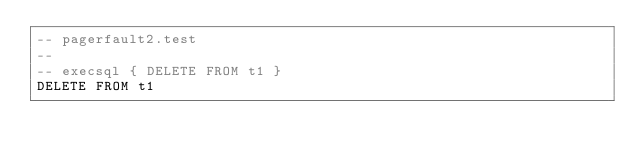<code> <loc_0><loc_0><loc_500><loc_500><_SQL_>-- pagerfault2.test
-- 
-- execsql { DELETE FROM t1 }
DELETE FROM t1</code> 